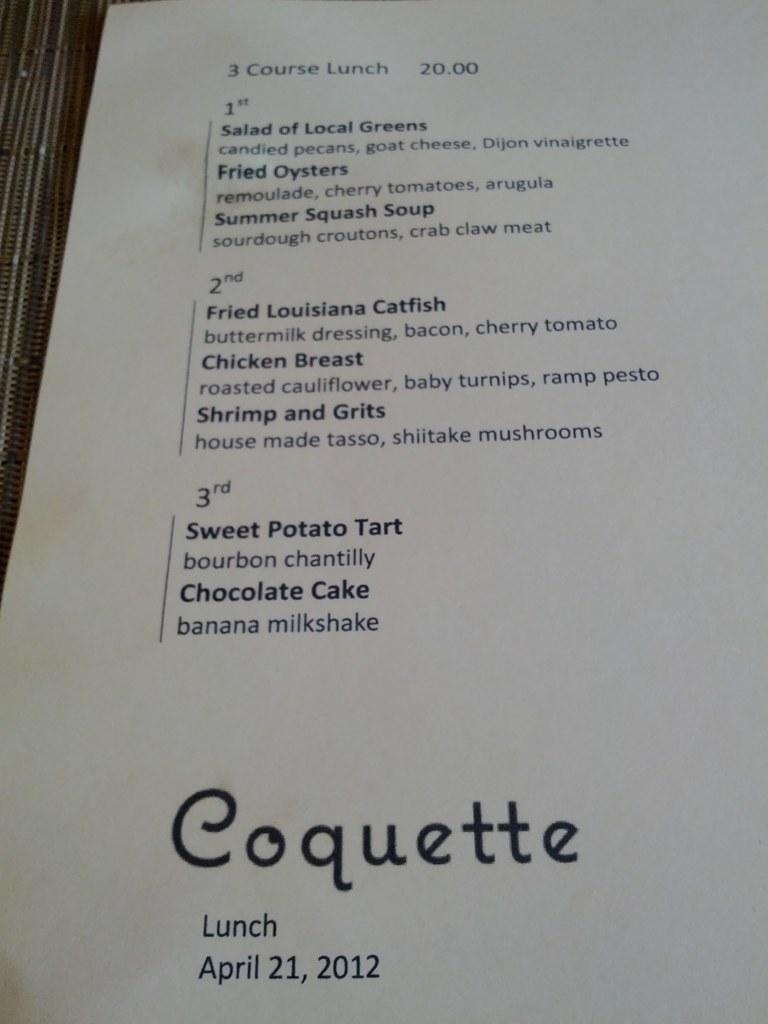<image>
Render a clear and concise summary of the photo. The pamphlet explained the 3 courses of lunch they offered at $20.00. 